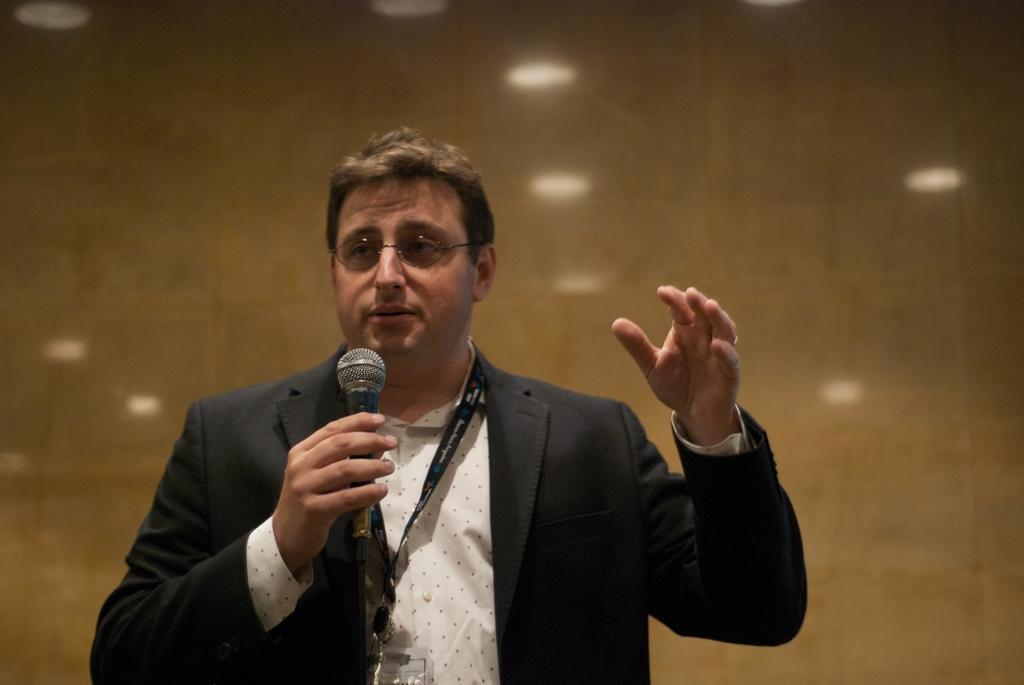Please provide a concise description of this image. In this picture we can see a man wearing black suit is holding a mic and he is having the spectacles and behind him there is wall in brown color. 